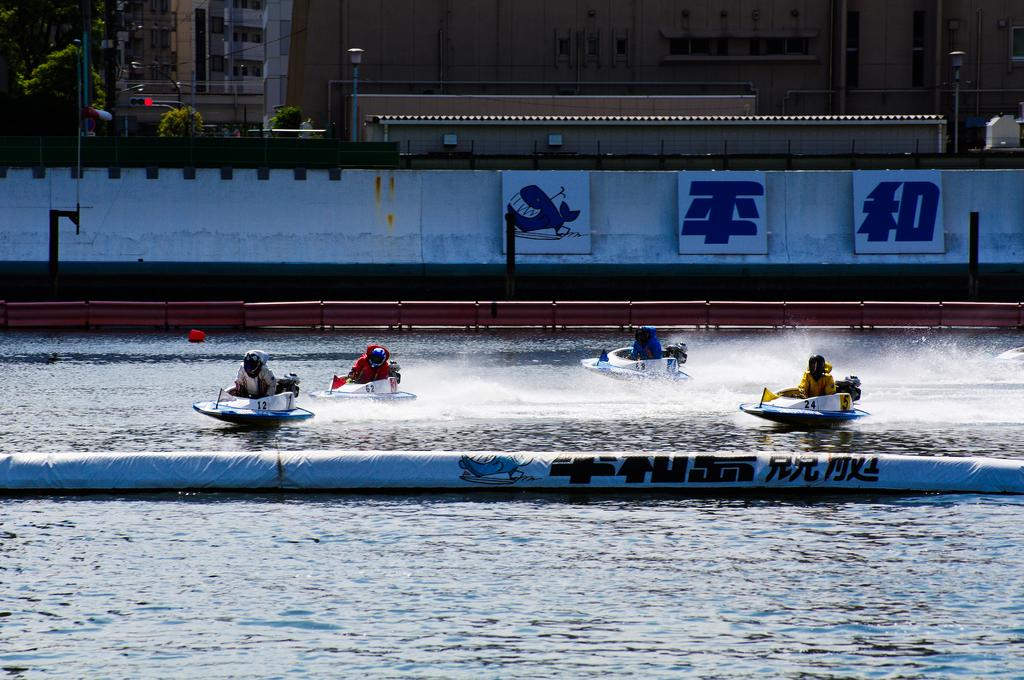What are the people in the image doing? The people in the image are riding boats on the water. What can be seen in the background of the image? In the background of the image, there is a wall, a fence, boards, plants, trees, poles, lights, and buildings. How many eggs are being used as bait by the people in the image? There is no mention of eggs or bait in the image; people are riding boats on the water. Can you describe the romantic gesture between the people in the image? There is no romantic gesture or kiss depicted in the image; people are riding boats on the water. 